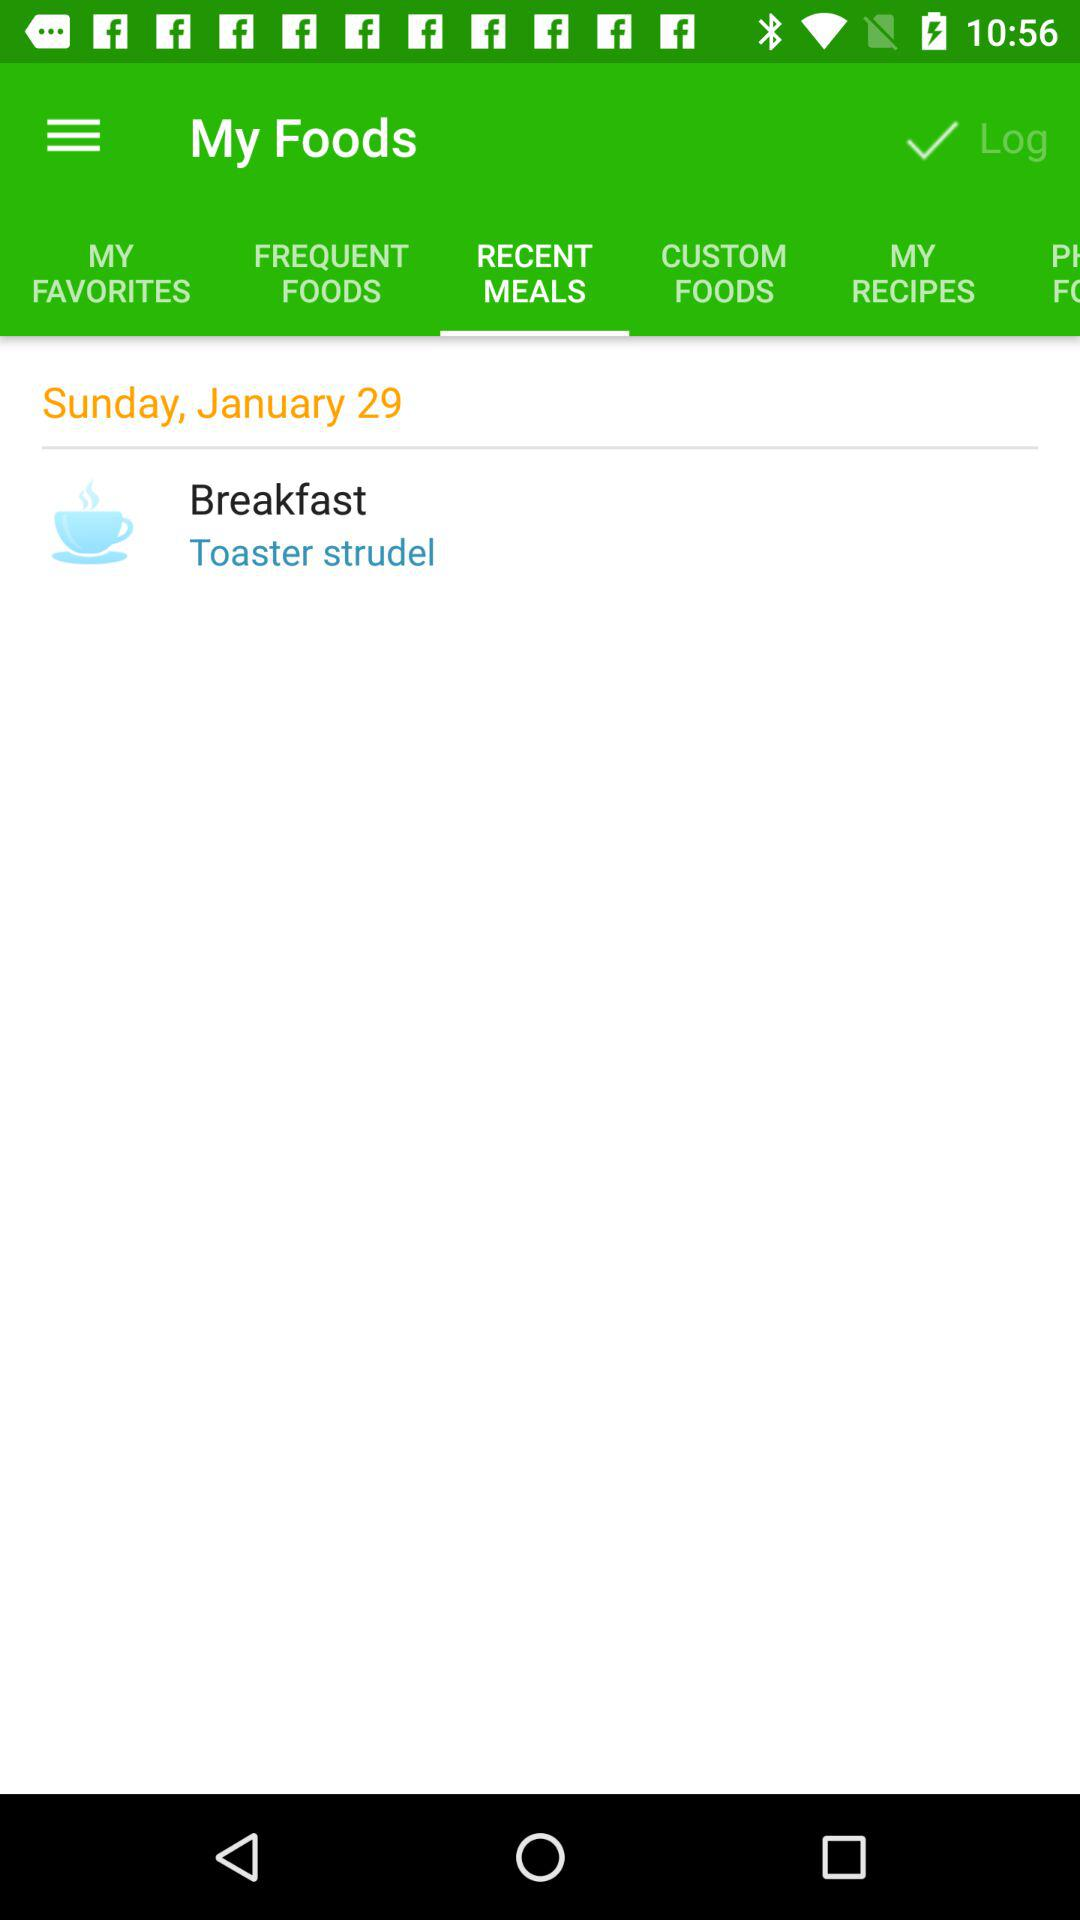What item is set for breakfast?
When the provided information is insufficient, respond with <no answer>. <no answer> 